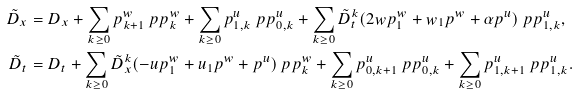<formula> <loc_0><loc_0><loc_500><loc_500>\tilde { D } _ { x } & = D _ { x } + \sum _ { k \geq 0 } p _ { k + 1 } ^ { w } \ p { p ^ { w } _ { k } } + \sum _ { k \geq 0 } p _ { 1 , k } ^ { u } \ p { p ^ { u } _ { 0 , k } } + \sum _ { k \geq 0 } \tilde { D } _ { t } ^ { k } ( 2 w p _ { 1 } ^ { w } + w _ { 1 } p ^ { w } + \alpha p ^ { u } ) \ p { p _ { 1 , k } ^ { u } } , \\ \tilde { D } _ { t } & = D _ { t } + \sum _ { k \geq 0 } \tilde { D } _ { x } ^ { k } ( - u p _ { 1 } ^ { w } + u _ { 1 } p ^ { w } + p ^ { u } ) \ p { p _ { k } ^ { w } } + \sum _ { k \geq 0 } p _ { 0 , k + 1 } ^ { u } \ p { p _ { 0 , k } ^ { u } } + \sum _ { k \geq 0 } p _ { 1 , k + 1 } ^ { u } \ p { p _ { 1 , k } ^ { u } } .</formula> 